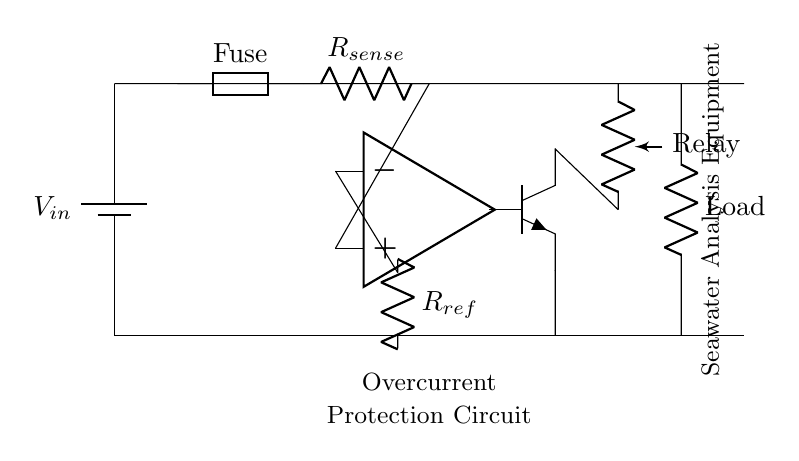What is the function of the fuse in this circuit? The fuse serves as a protective device that breaks the circuit when the current exceeds a certain threshold, preventing damage to the components.
Answer: Protective device What is the reference resistor value in this circuit? The reference resistor, labeled as R_ref, sets the threshold value for the comparator to determine overcurrent conditions.
Answer: R_ref What component detects the overcurrent condition in the circuit? The comparator is responsible for comparing the voltage across the sense resistor with the reference voltage to decide whether an overcurrent condition exists.
Answer: Comparator How does the transistor interact with the relay? When the comparator detects overcurrent, it activates the transistor, allowing current to flow to the relay, which then opens the circuit to protect the load.
Answer: Activates What is the primary purpose of the current sense resistor? The current sense resistor, labeled R_sense, is used to measure the current flowing through the circuit by generating a voltage drop that the comparator can measure.
Answer: Measure current What type of circuit is this classified as? This circuit is classified as an overcurrent protection circuit because its primary role is to prevent excessive current from flowing through sensitive equipment.
Answer: Protection circuit 